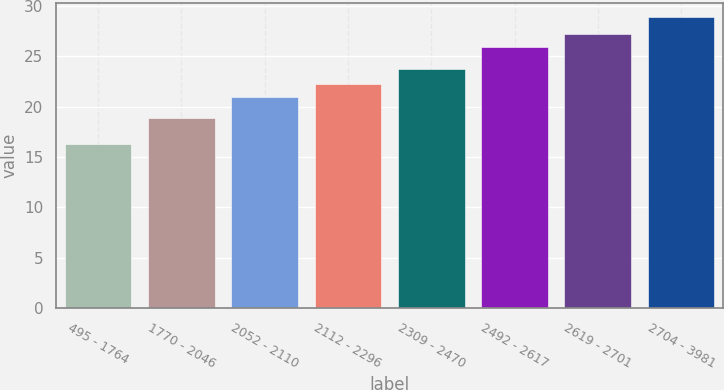<chart> <loc_0><loc_0><loc_500><loc_500><bar_chart><fcel>495 - 1764<fcel>1770 - 2046<fcel>2052 - 2110<fcel>2112 - 2296<fcel>2309 - 2470<fcel>2492 - 2617<fcel>2619 - 2701<fcel>2704 - 3981<nl><fcel>16.26<fcel>18.9<fcel>20.95<fcel>22.21<fcel>23.69<fcel>25.89<fcel>27.15<fcel>28.83<nl></chart> 